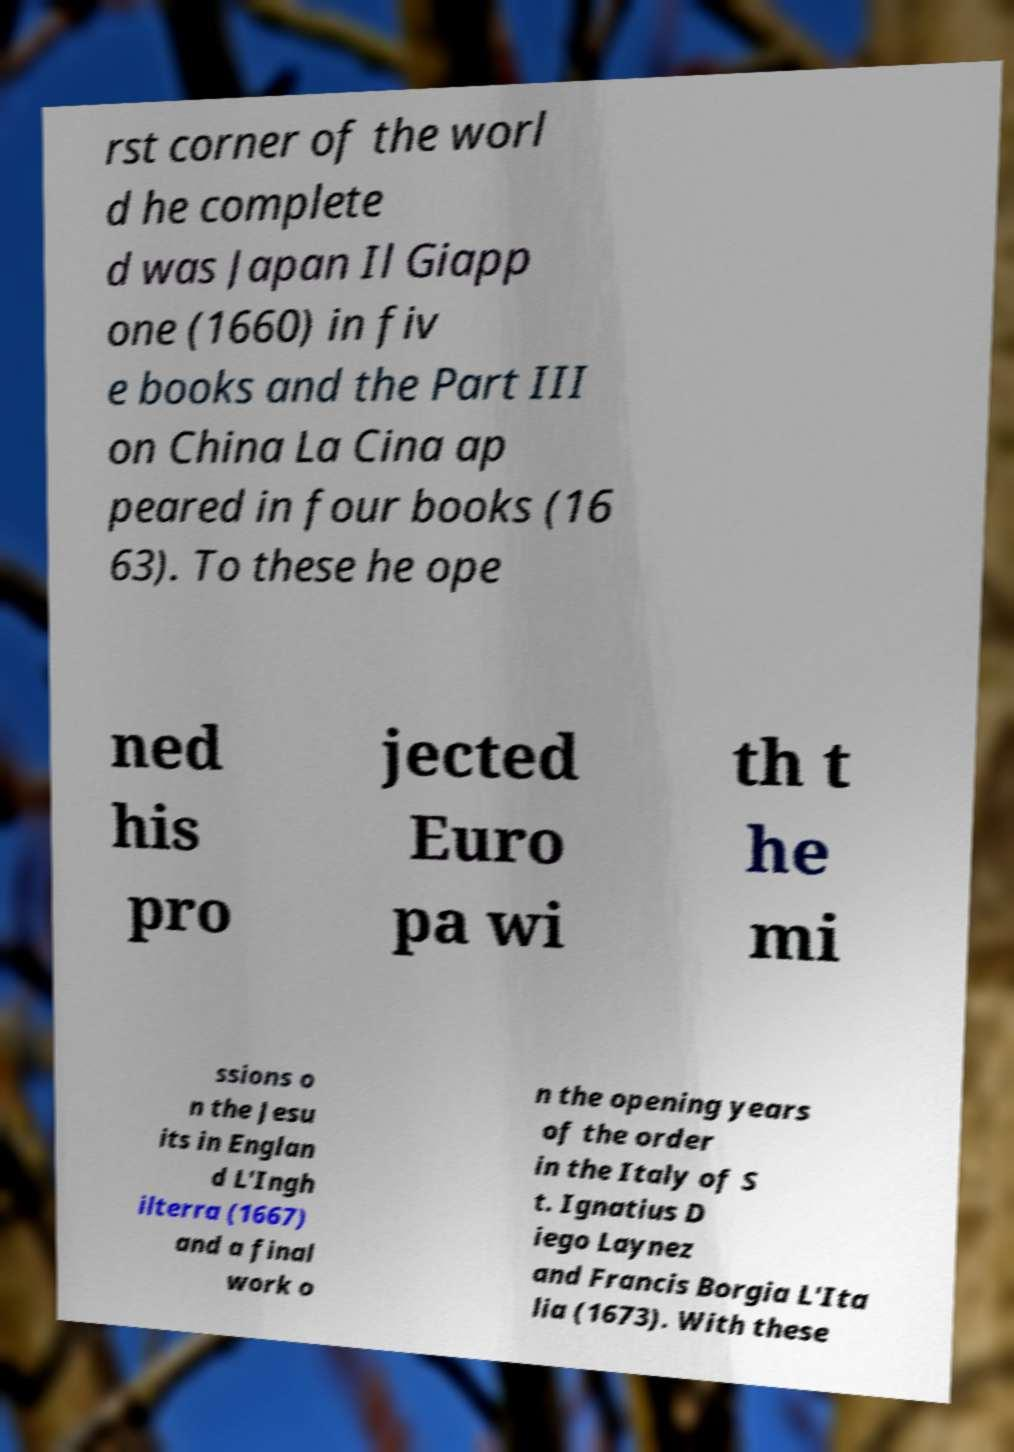Can you accurately transcribe the text from the provided image for me? rst corner of the worl d he complete d was Japan Il Giapp one (1660) in fiv e books and the Part III on China La Cina ap peared in four books (16 63). To these he ope ned his pro jected Euro pa wi th t he mi ssions o n the Jesu its in Englan d L'Ingh ilterra (1667) and a final work o n the opening years of the order in the Italy of S t. Ignatius D iego Laynez and Francis Borgia L'Ita lia (1673). With these 